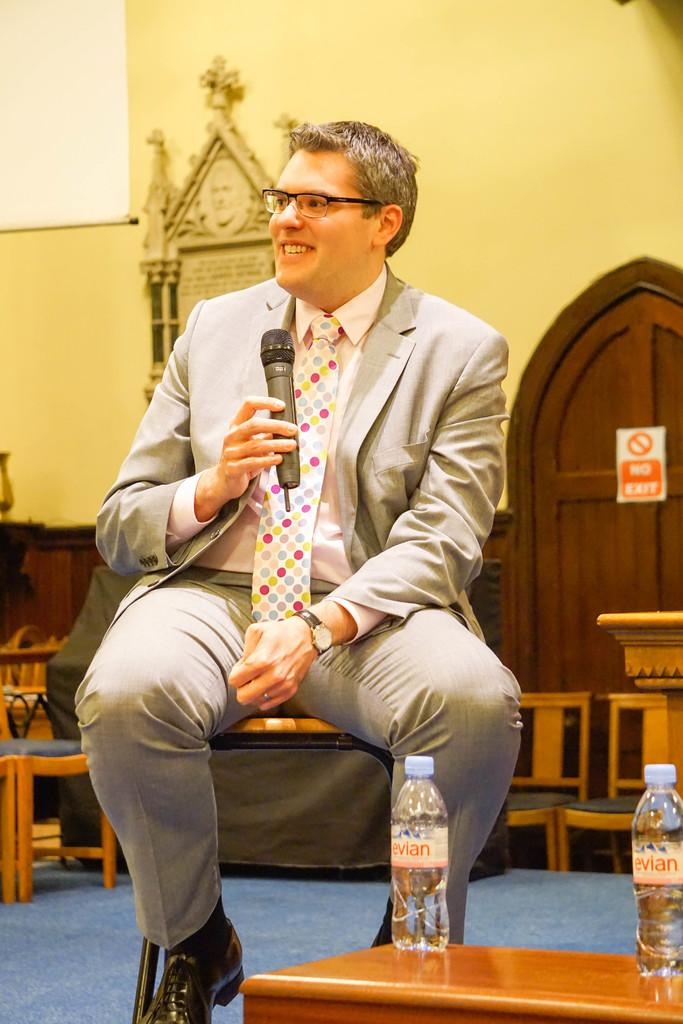What is the man in the image doing? The man is sitting on a chair in the image. What type of clothing is the man wearing? The man is wearing a coat and a tie. What accessory is the man wearing on his wrist? The man is wearing a watch. What object is the man holding in the image? The man is holding a mic. What type of rice can be seen cooking in the image? There is no rice present in the image. Can you tell me how the stranger is interacting with the man in the image? There is no stranger present in the image. What type of hole can be seen in the image? There is no hole present in the image. 